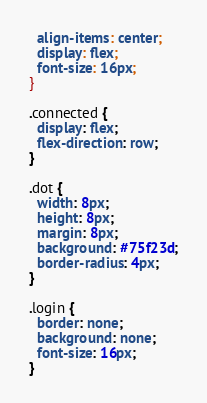Convert code to text. <code><loc_0><loc_0><loc_500><loc_500><_CSS_>  align-items: center;
  display: flex;
  font-size: 16px;
}

.connected {
  display: flex;
  flex-direction: row;
}

.dot {
  width: 8px;
  height: 8px;
  margin: 8px;
  background: #75f23d;
  border-radius: 4px;
}

.login {
  border: none;
  background: none;
  font-size: 16px;
}
</code> 